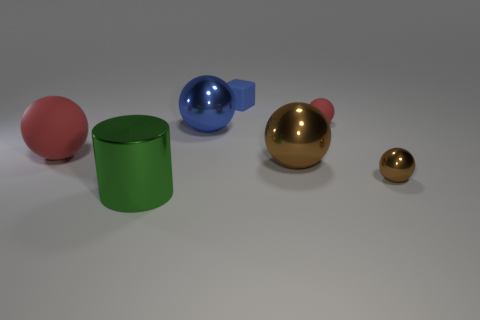Subtract all blue balls. How many balls are left? 4 Subtract all tiny matte spheres. How many spheres are left? 4 Subtract 2 balls. How many balls are left? 3 Subtract all cyan balls. Subtract all gray cylinders. How many balls are left? 5 Add 1 tiny blue objects. How many objects exist? 8 Subtract all balls. How many objects are left? 2 Subtract all red matte objects. Subtract all big purple cylinders. How many objects are left? 5 Add 4 big rubber spheres. How many big rubber spheres are left? 5 Add 5 red balls. How many red balls exist? 7 Subtract 0 red blocks. How many objects are left? 7 